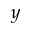Convert formula to latex. <formula><loc_0><loc_0><loc_500><loc_500>y</formula> 